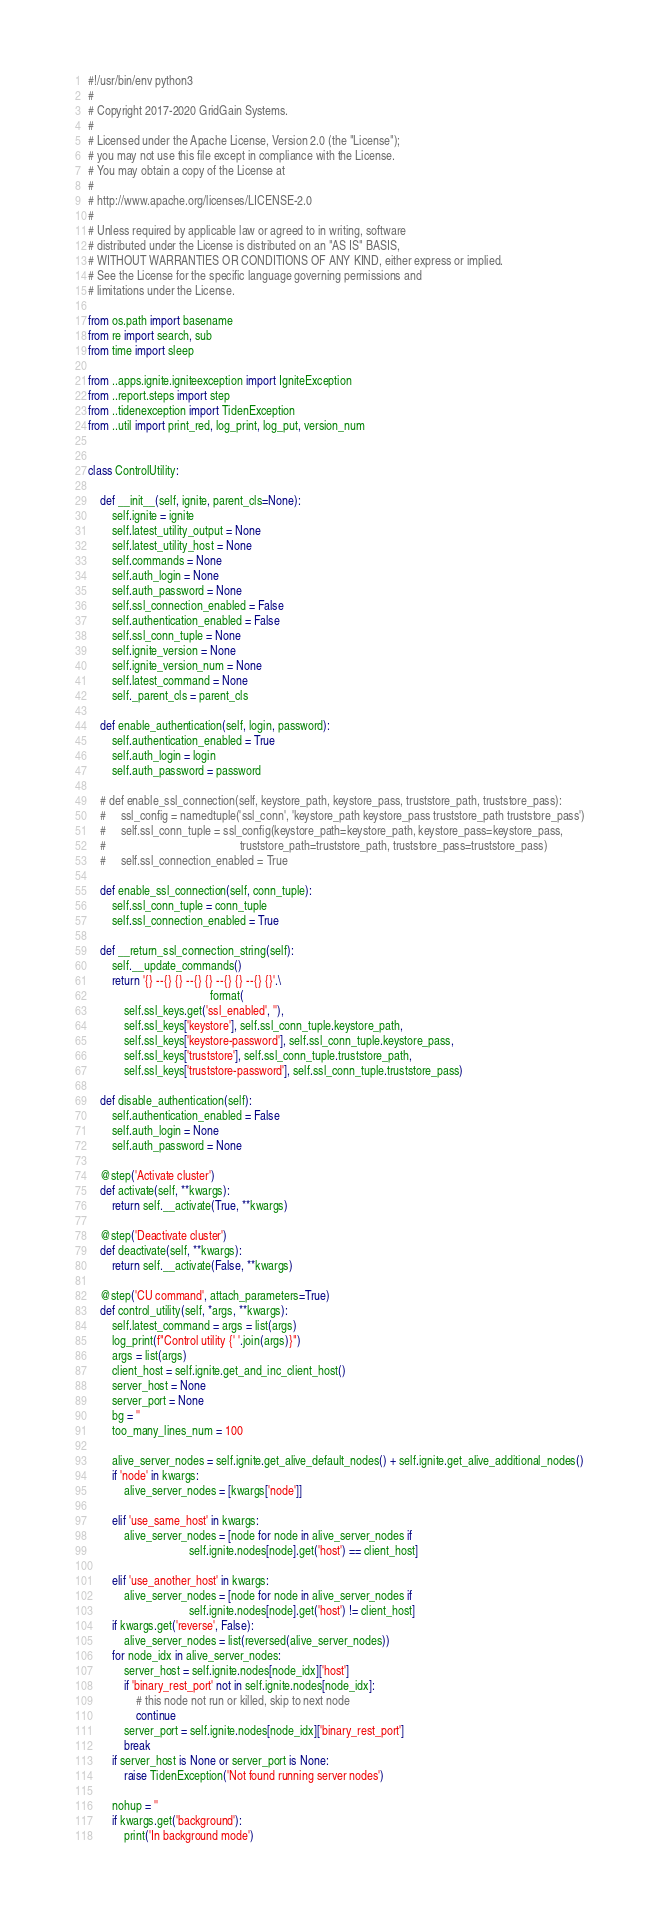Convert code to text. <code><loc_0><loc_0><loc_500><loc_500><_Python_>#!/usr/bin/env python3
#
# Copyright 2017-2020 GridGain Systems.
#
# Licensed under the Apache License, Version 2.0 (the "License");
# you may not use this file except in compliance with the License.
# You may obtain a copy of the License at
#
# http://www.apache.org/licenses/LICENSE-2.0
#
# Unless required by applicable law or agreed to in writing, software
# distributed under the License is distributed on an "AS IS" BASIS,
# WITHOUT WARRANTIES OR CONDITIONS OF ANY KIND, either express or implied.
# See the License for the specific language governing permissions and
# limitations under the License.

from os.path import basename
from re import search, sub
from time import sleep

from ..apps.ignite.igniteexception import IgniteException
from ..report.steps import step
from ..tidenexception import TidenException
from ..util import print_red, log_print, log_put, version_num


class ControlUtility:

    def __init__(self, ignite, parent_cls=None):
        self.ignite = ignite
        self.latest_utility_output = None
        self.latest_utility_host = None
        self.commands = None
        self.auth_login = None
        self.auth_password = None
        self.ssl_connection_enabled = False
        self.authentication_enabled = False
        self.ssl_conn_tuple = None
        self.ignite_version = None
        self.ignite_version_num = None
        self.latest_command = None
        self._parent_cls = parent_cls

    def enable_authentication(self, login, password):
        self.authentication_enabled = True
        self.auth_login = login
        self.auth_password = password

    # def enable_ssl_connection(self, keystore_path, keystore_pass, truststore_path, truststore_pass):
    #     ssl_config = namedtuple('ssl_conn', 'keystore_path keystore_pass truststore_path truststore_pass')
    #     self.ssl_conn_tuple = ssl_config(keystore_path=keystore_path, keystore_pass=keystore_pass,
    #                                             truststore_path=truststore_path, truststore_pass=truststore_pass)
    #     self.ssl_connection_enabled = True

    def enable_ssl_connection(self, conn_tuple):
        self.ssl_conn_tuple = conn_tuple
        self.ssl_connection_enabled = True

    def __return_ssl_connection_string(self):
        self.__update_commands()
        return '{} --{} {} --{} {} --{} {} --{} {}'.\
                                         format(
            self.ssl_keys.get('ssl_enabled', ''),
            self.ssl_keys['keystore'], self.ssl_conn_tuple.keystore_path,
            self.ssl_keys['keystore-password'], self.ssl_conn_tuple.keystore_pass,
            self.ssl_keys['truststore'], self.ssl_conn_tuple.truststore_path,
            self.ssl_keys['truststore-password'], self.ssl_conn_tuple.truststore_pass)

    def disable_authentication(self):
        self.authentication_enabled = False
        self.auth_login = None
        self.auth_password = None

    @step('Activate cluster')
    def activate(self, **kwargs):
        return self.__activate(True, **kwargs)

    @step('Deactivate cluster')
    def deactivate(self, **kwargs):
        return self.__activate(False, **kwargs)

    @step('CU command', attach_parameters=True)
    def control_utility(self, *args, **kwargs):
        self.latest_command = args = list(args)
        log_print(f"Control utility {' '.join(args)}")
        args = list(args)
        client_host = self.ignite.get_and_inc_client_host()
        server_host = None
        server_port = None
        bg = ''
        too_many_lines_num = 100

        alive_server_nodes = self.ignite.get_alive_default_nodes() + self.ignite.get_alive_additional_nodes()
        if 'node' in kwargs:
            alive_server_nodes = [kwargs['node']]

        elif 'use_same_host' in kwargs:
            alive_server_nodes = [node for node in alive_server_nodes if
                                  self.ignite.nodes[node].get('host') == client_host]

        elif 'use_another_host' in kwargs:
            alive_server_nodes = [node for node in alive_server_nodes if
                                  self.ignite.nodes[node].get('host') != client_host]
        if kwargs.get('reverse', False):
            alive_server_nodes = list(reversed(alive_server_nodes))
        for node_idx in alive_server_nodes:
            server_host = self.ignite.nodes[node_idx]['host']
            if 'binary_rest_port' not in self.ignite.nodes[node_idx]:
                # this node not run or killed, skip to next node
                continue
            server_port = self.ignite.nodes[node_idx]['binary_rest_port']
            break
        if server_host is None or server_port is None:
            raise TidenException('Not found running server nodes')

        nohup = ''
        if kwargs.get('background'):
            print('In background mode')</code> 